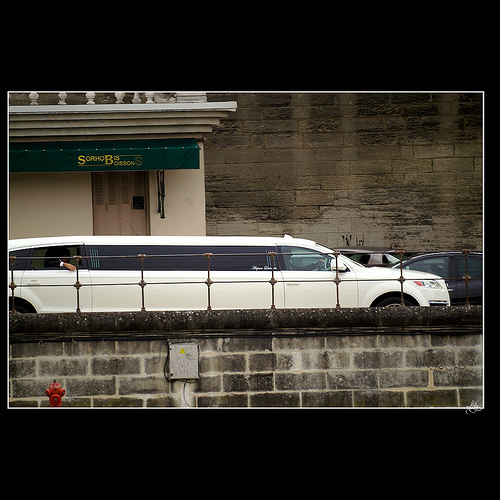<image>
Is there a car behind the building? Yes. From this viewpoint, the car is positioned behind the building, with the building partially or fully occluding the car. 